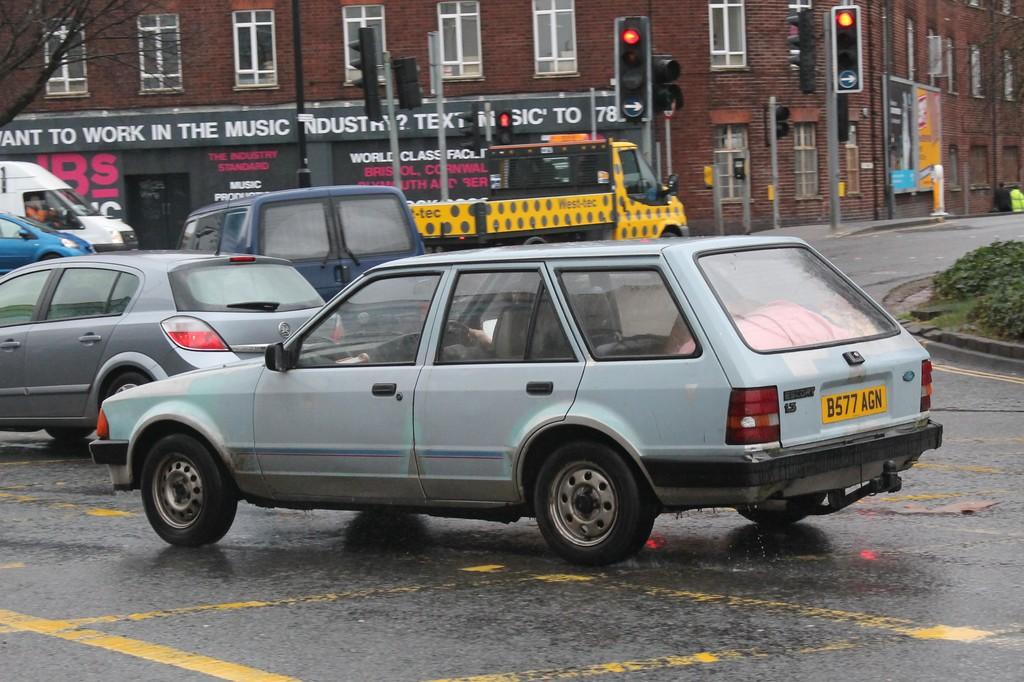<image>
Create a compact narrative representing the image presented. A car with the license plate B577 AGN drives on a crowded street. 